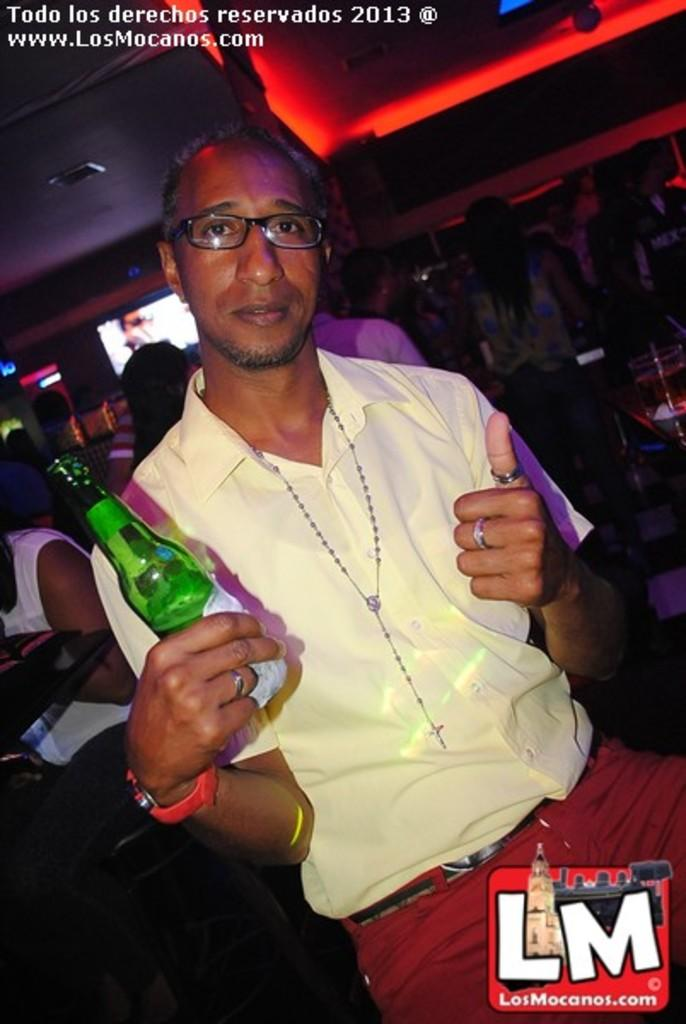What is the main subject of the picture? The main subject of the picture is a man. Can you describe the man's appearance? The man is wearing spectacles. What is the man holding in the picture? The man is holding a bottle in one hand. What is the man's posture in the image? The man is sitting. What can be seen in the background of the image? There are other persons, a wall, a pillar, and a window in the background of the image. How would you describe the lighting in the image? The image appears to be dark. Where is the shelf located in the image? There is no shelf present in the image. What type of stamp can be seen on the man's forehead in the image? There is no stamp on the man's forehead in the image. 